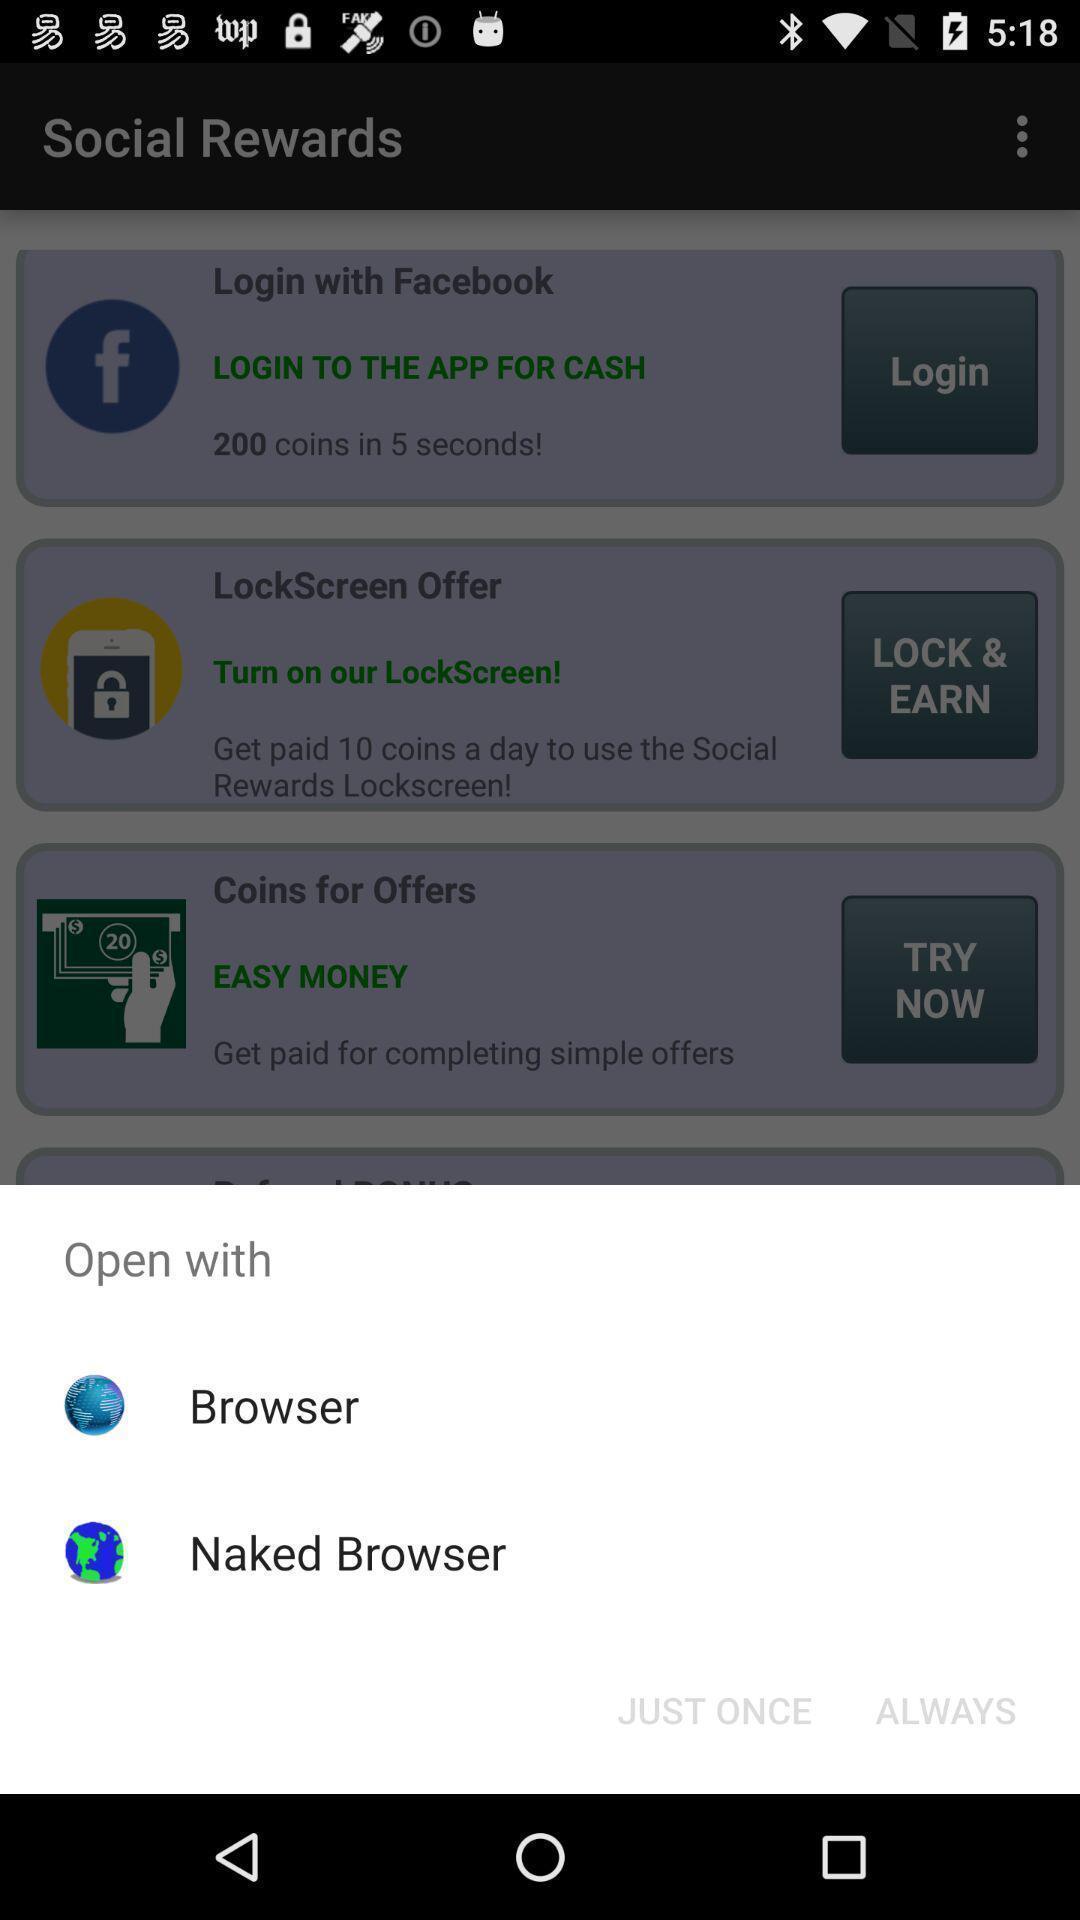Describe the key features of this screenshot. Push up page displaying to open via other application. 